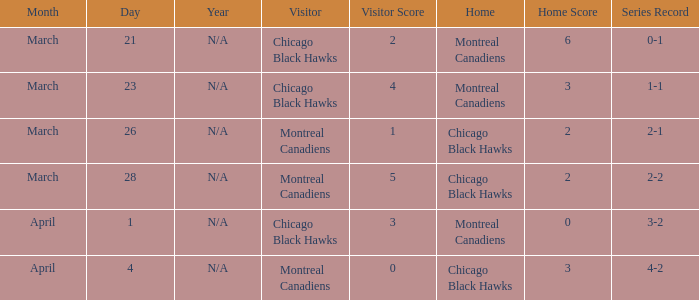What is the score for the team with a record of 2-1? 1–2. 